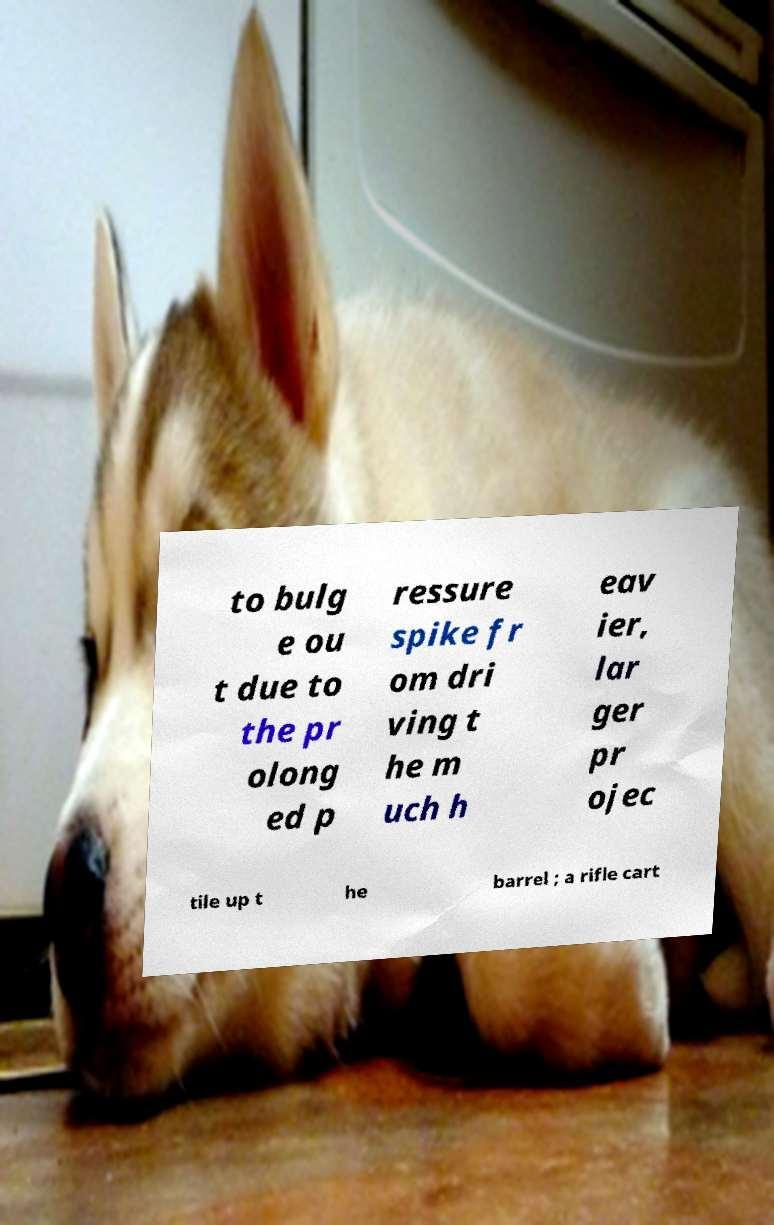I need the written content from this picture converted into text. Can you do that? to bulg e ou t due to the pr olong ed p ressure spike fr om dri ving t he m uch h eav ier, lar ger pr ojec tile up t he barrel ; a rifle cart 